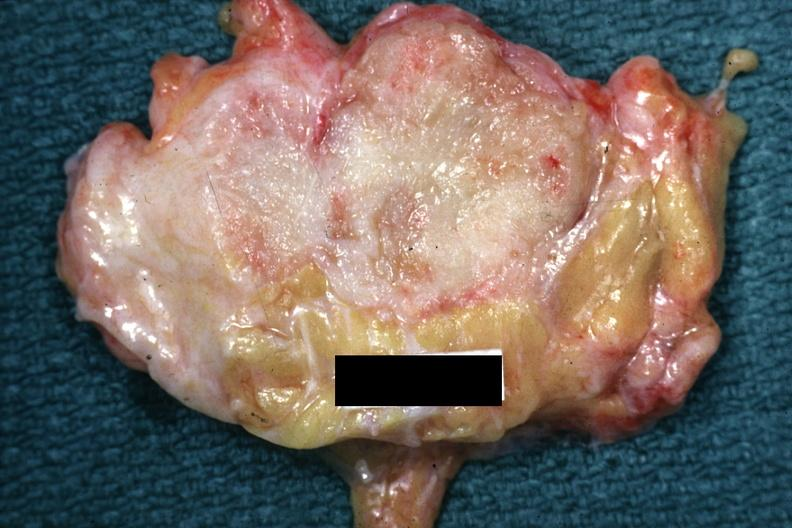what is present?
Answer the question using a single word or phrase. Adenocarcinoma 